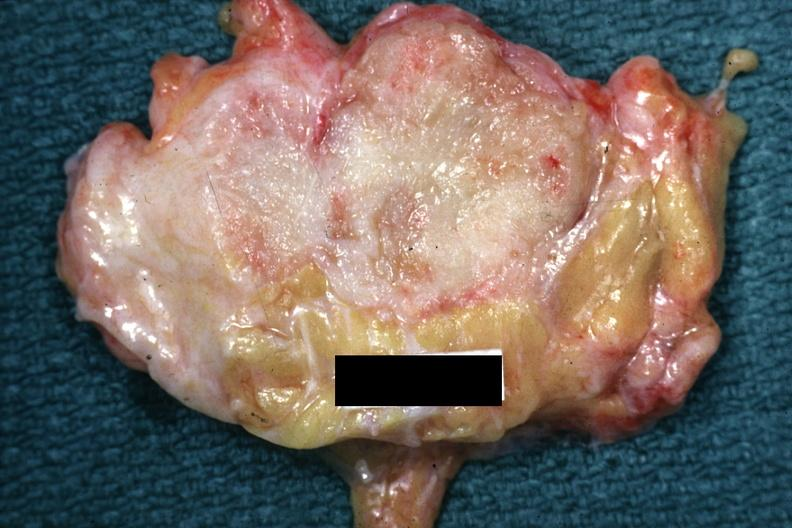what is present?
Answer the question using a single word or phrase. Adenocarcinoma 